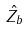Convert formula to latex. <formula><loc_0><loc_0><loc_500><loc_500>\hat { Z _ { b } }</formula> 